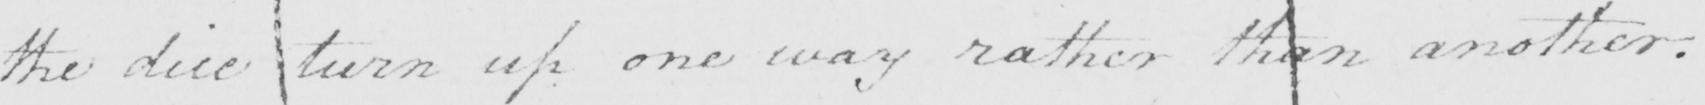What text is written in this handwritten line? the dice turn up one way rather than another . 